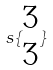Convert formula to latex. <formula><loc_0><loc_0><loc_500><loc_500>s \{ \begin{matrix} 3 \\ 3 \end{matrix} \}</formula> 